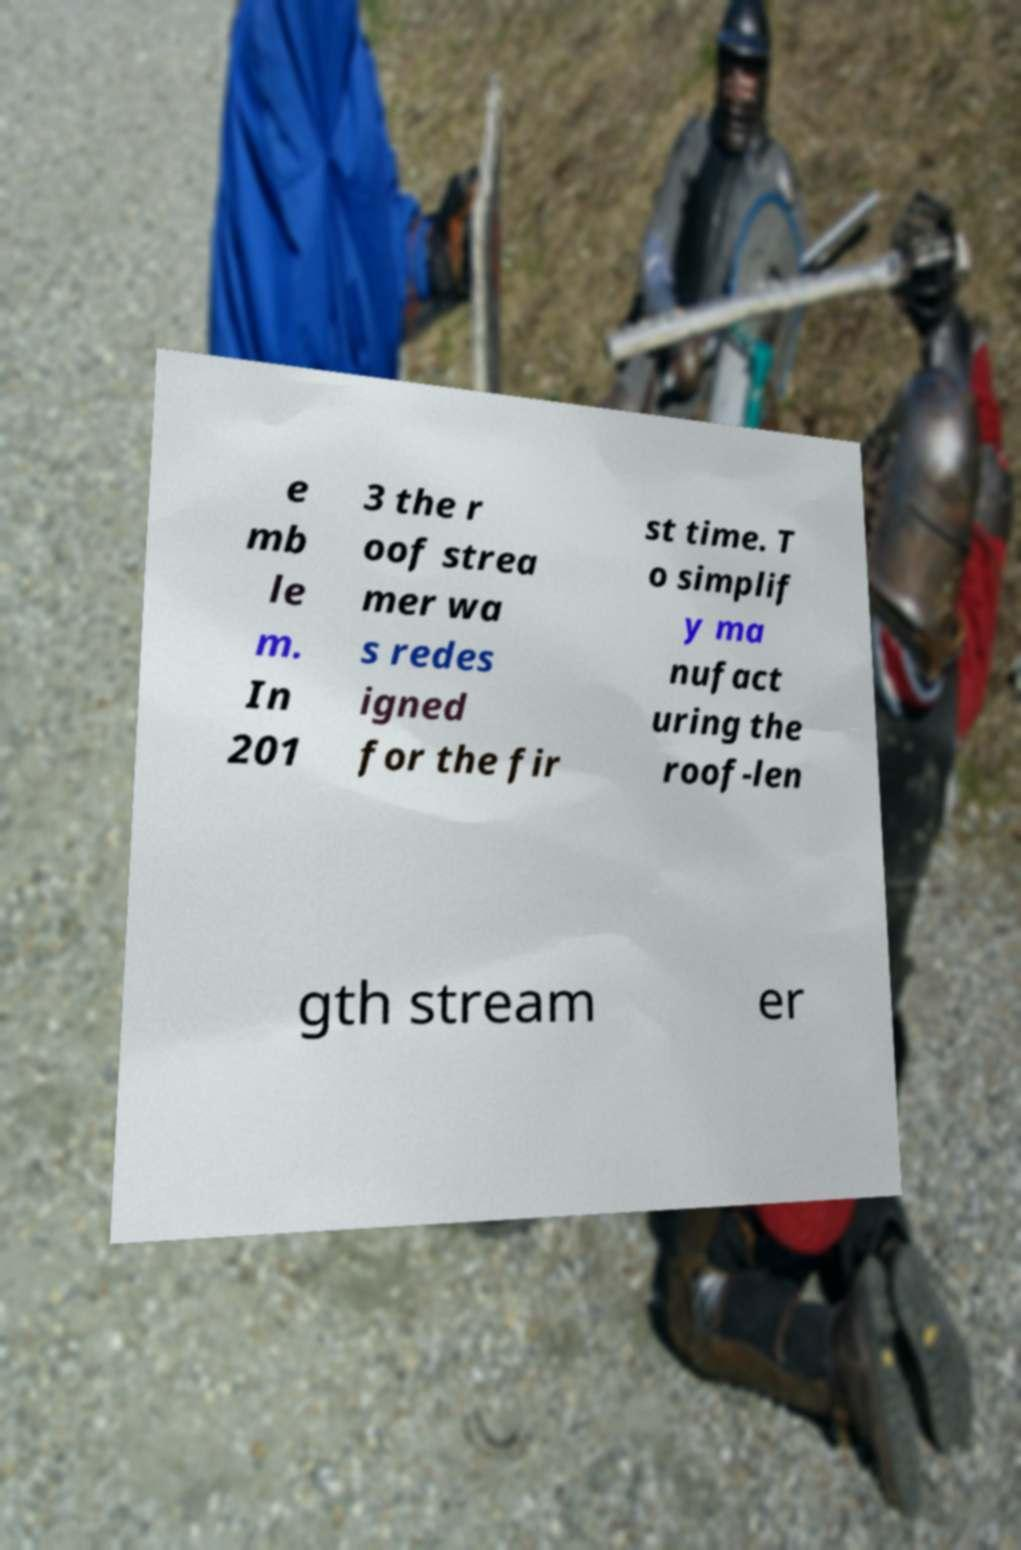I need the written content from this picture converted into text. Can you do that? e mb le m. In 201 3 the r oof strea mer wa s redes igned for the fir st time. T o simplif y ma nufact uring the roof-len gth stream er 